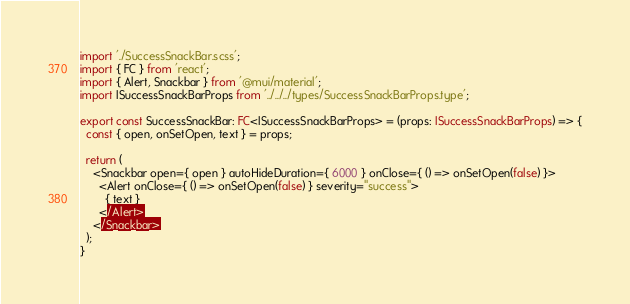<code> <loc_0><loc_0><loc_500><loc_500><_TypeScript_>import './SuccessSnackBar.scss';
import { FC } from 'react';
import { Alert, Snackbar } from '@mui/material';
import ISuccessSnackBarProps from '../../../types/SuccessSnackBarProps.type';

export const SuccessSnackBar: FC<ISuccessSnackBarProps> = (props: ISuccessSnackBarProps) => {
  const { open, onSetOpen, text } = props;

  return (
    <Snackbar open={ open } autoHideDuration={ 6000 } onClose={ () => onSetOpen(false) }>
      <Alert onClose={ () => onSetOpen(false) } severity="success">
        { text }
      </Alert>
    </Snackbar>
  );
}</code> 